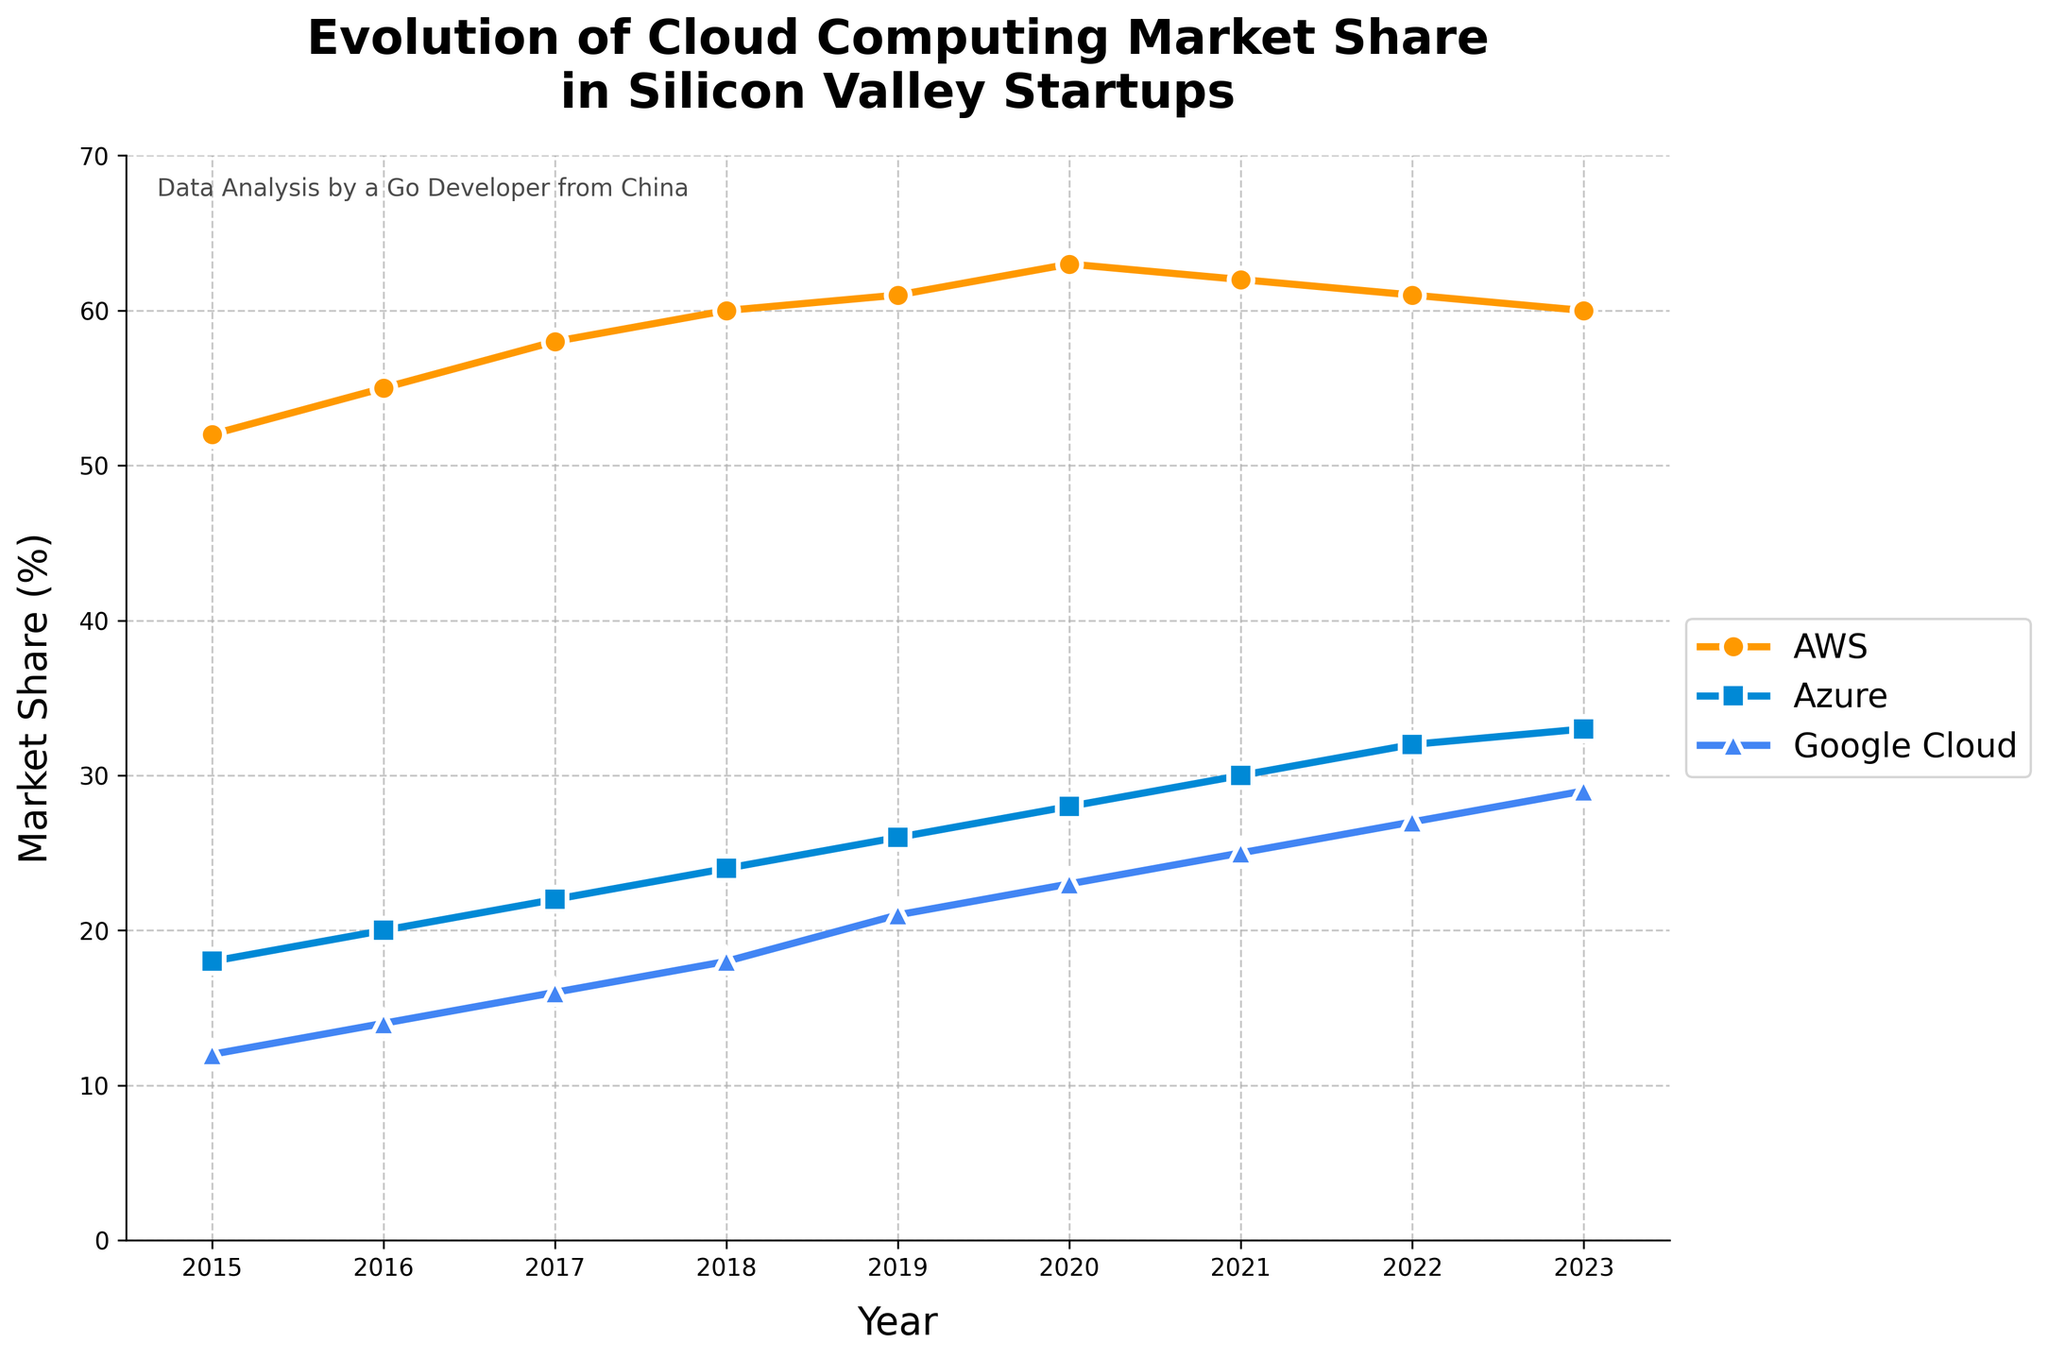What year did AWS reach its maximum market share? By examining the data points for AWS, AWS reached its maximum market share in 2020 with a market share of 63%.
Answer: 2020 By how much did Google Cloud's market share increase from 2015 to 2023? The market share of Google Cloud in 2015 was 12%, and in 2023 it was 29%. The increase is calculated by subtracting the 2015 value from the 2023 value: 29% - 12% = 17%.
Answer: 17% Which provider has the smallest market share in 2023? In 2023, AWS had 60%, Azure had 33%, and Google Cloud had 29%. Google Cloud has the smallest market share in 2023.
Answer: Google Cloud What is the total market share of AWS and Azure in 2018? In 2018, AWS had a market share of 60% and Azure had 24%. Adding these values together gives 60% + 24% = 84%.
Answer: 84% In which year did Azure's market share surpass 25%? By analyzing the data points for Azure, Azure surpassed 25% market share in 2019, where it had a market share of 26%.
Answer: 2019 By how much did AWS's market share change from 2019 to 2021? The market share of AWS in 2019 was 61%, and in 2021 it was 62%. The change in market share is 62% - 61% = 1%.
Answer: 1% What is the average market share of Azure from 2015 to 2023? To find the average market share of Azure from 2015 to 2023, sum up the yearly values and divide by the number of years: (18 + 20 + 22 + 24 + 26 + 28 + 30 + 32 + 33) / 9 = 233 / 9 ≈ 25.89%.
Answer: 25.89% Which provider showed consistent growth in market share every year? By comparing the data trends, both Azure and Google Cloud showed consistent growth in market share every year from 2015 to 2023.
Answer: Azure and Google Cloud In which year was the gap between AWS and Google Cloud the largest? Calculating the difference between AWS and Google Cloud's market share each year, the largest gap was in 2015 with a difference of 52% - 12% = 40%.
Answer: 2015 